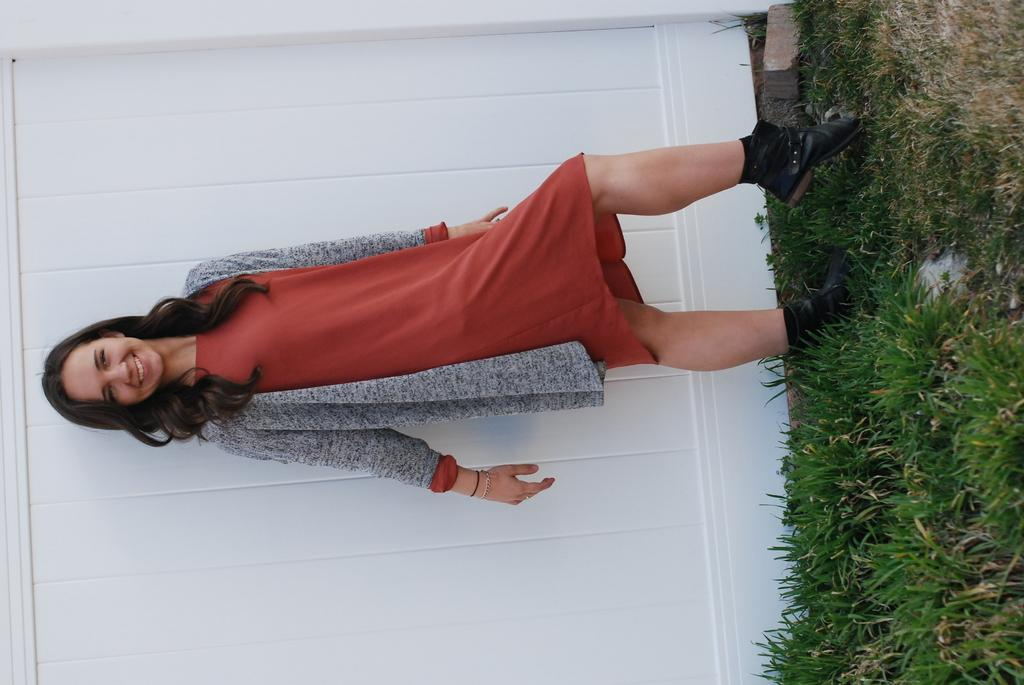What is the main subject of the image? The main subject of the image is a woman. What is the woman doing in the image? The woman is standing on the grass. What is the woman wearing in the image? The woman is wearing a red dress. What type of cub can be seen playing with the woman in the image? There is no cub present in the image, and therefore no such activity can be observed. 